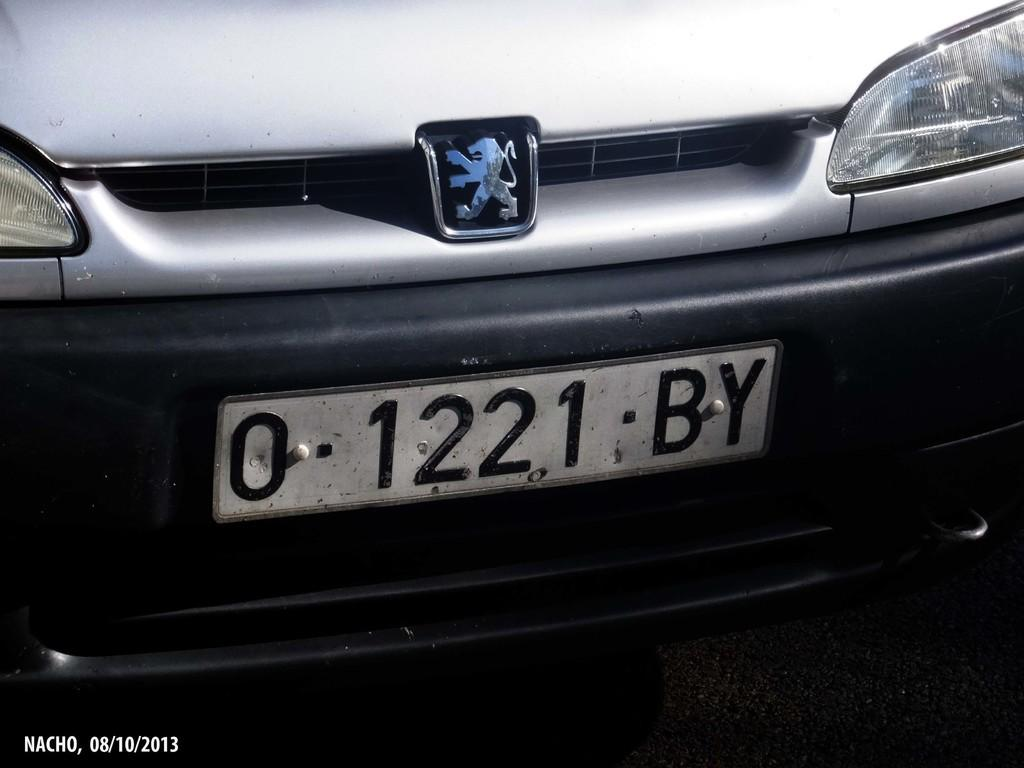What is the main subject of the image? The main subject of the image is a vehicle. How is the vehicle shown in the image? The vehicle is shown from the front. What is a feature found on the vehicle? There is a number plate on the vehicle. What can be seen on the vehicle that might be used for illumination? There are lights on the vehicle. What information is provided at the bottom of the image? There is some text at the bottom of the image. What type of desk can be seen in the image? There is no desk present in the image; it features a vehicle shown from the front. How many attempts were made to fold the sheet in the image? There is no sheet or folding activity present in the image. 